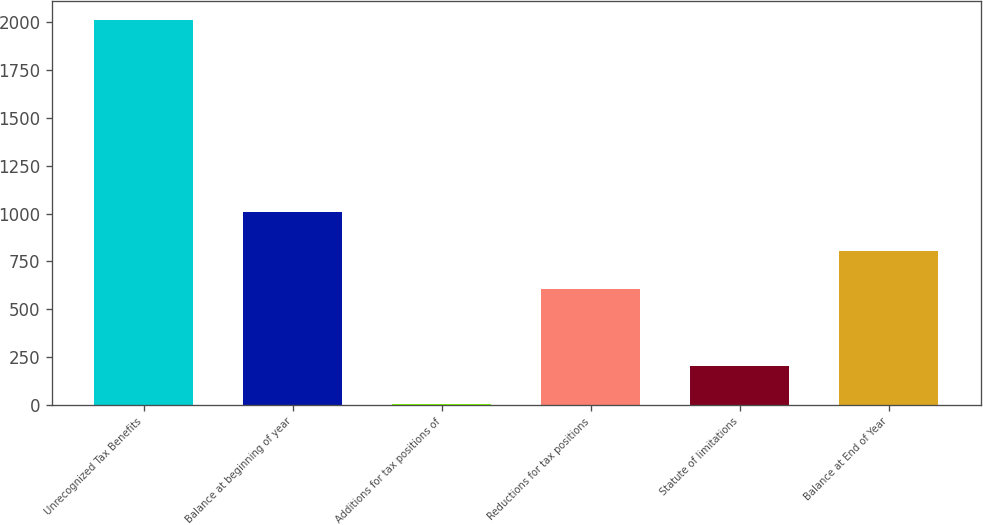Convert chart to OTSL. <chart><loc_0><loc_0><loc_500><loc_500><bar_chart><fcel>Unrecognized Tax Benefits<fcel>Balance at beginning of year<fcel>Additions for tax positions of<fcel>Reductions for tax positions<fcel>Statute of limitations<fcel>Balance at End of Year<nl><fcel>2012<fcel>1007.15<fcel>2.3<fcel>605.21<fcel>203.27<fcel>806.18<nl></chart> 